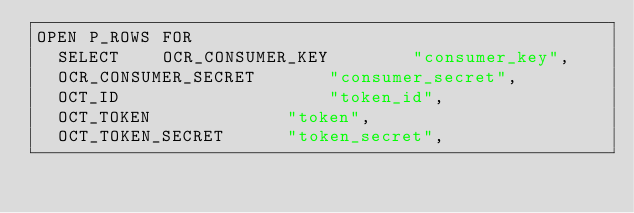<code> <loc_0><loc_0><loc_500><loc_500><_SQL_>OPEN P_ROWS FOR
  SELECT	OCR_CONSUMER_KEY		"consumer_key",
  OCR_CONSUMER_SECRET		"consumer_secret",
  OCT_ID					"token_id",
  OCT_TOKEN				"token",
  OCT_TOKEN_SECRET		"token_secret",</code> 